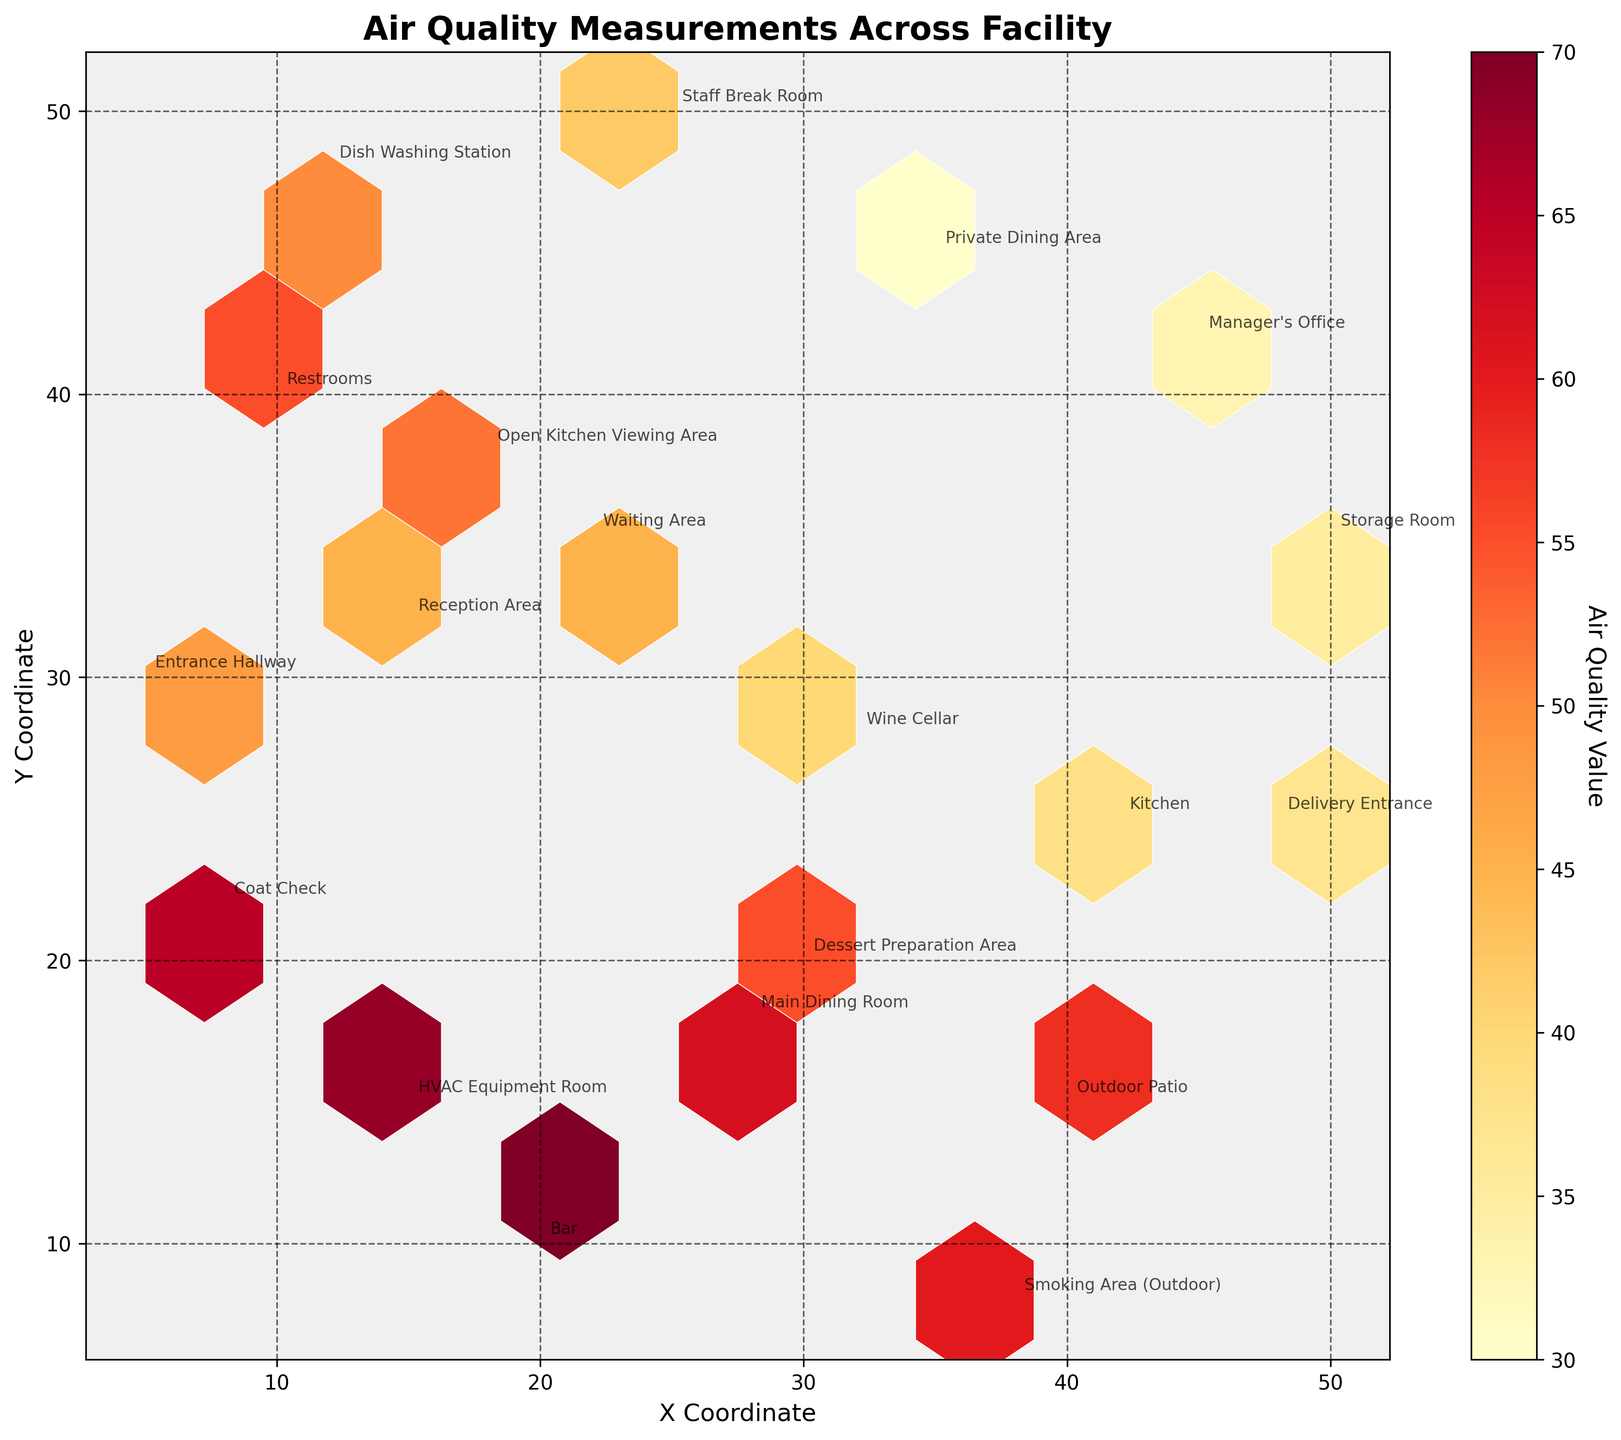How many different locations are represented in the plot? Count the unique labels for 'location' in the plot.
Answer: 20 What is the range of air quality values represented by the color bar? Observe the minimum and maximum values indicated on the color bar.
Answer: 30 to 70 Which location has the highest air quality value? Identify the point with the highest color intensity and read the annotated label.
Answer: Bar What are the coordinates for the main dining room? Locate the label for 'Main Dining Room' and read its coordinates.
Answer: (28, 18) How many hexagons are there in the hexbin plot? Visually count the hexagons shown in the plot or estimate based on the grid size and area coverage.
Answer: Various hexagons (exact count depends on visual estimation) Which two locations have similar air quality values around 50? Compare the annotations and air quality values for points around 50.
Answer: Outdoor Patio, Dish Washing Station Does the storage room have a better air quality value than the manager's office? Compare the storage room value (35) with the manager's office value (33).
Answer: No What is the average air quality value for the HVAC Equipment Room and the Coat Check? Sum the values and divide by the number of locations: (68 + 65) / 2.
Answer: 66.5 Is the air quality in the kitchen below or above 40? Check the air quality value for the kitchen location.
Answer: Below 40 Which areas have air quality values below 35? Identify and list locations with air quality values less than 35.
Answer: Manager's Office, Storage Room 